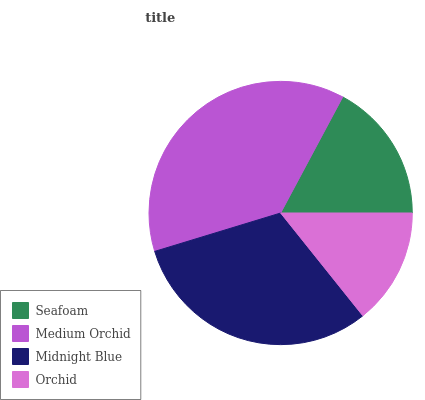Is Orchid the minimum?
Answer yes or no. Yes. Is Medium Orchid the maximum?
Answer yes or no. Yes. Is Midnight Blue the minimum?
Answer yes or no. No. Is Midnight Blue the maximum?
Answer yes or no. No. Is Medium Orchid greater than Midnight Blue?
Answer yes or no. Yes. Is Midnight Blue less than Medium Orchid?
Answer yes or no. Yes. Is Midnight Blue greater than Medium Orchid?
Answer yes or no. No. Is Medium Orchid less than Midnight Blue?
Answer yes or no. No. Is Midnight Blue the high median?
Answer yes or no. Yes. Is Seafoam the low median?
Answer yes or no. Yes. Is Medium Orchid the high median?
Answer yes or no. No. Is Medium Orchid the low median?
Answer yes or no. No. 